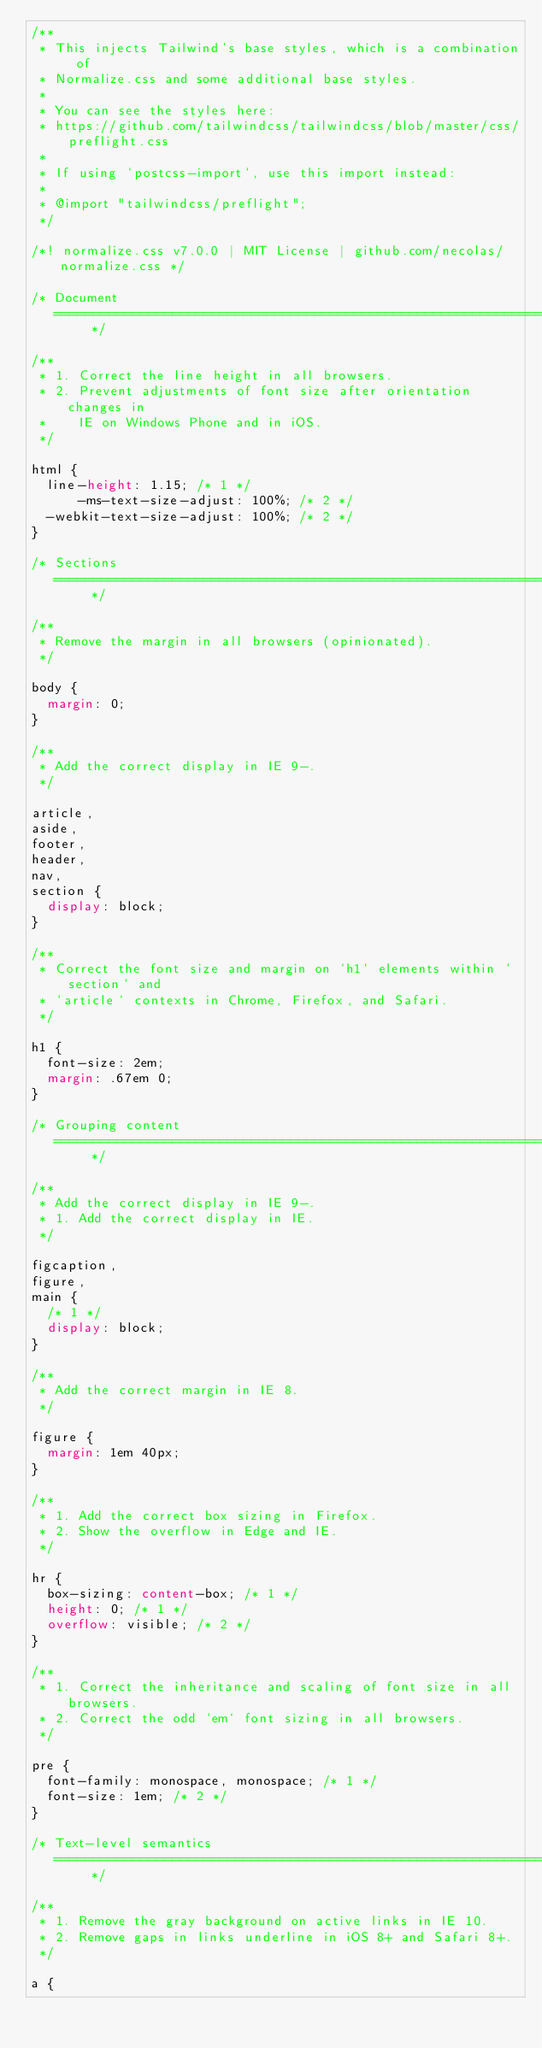<code> <loc_0><loc_0><loc_500><loc_500><_CSS_>/**
 * This injects Tailwind's base styles, which is a combination of
 * Normalize.css and some additional base styles.
 *
 * You can see the styles here:
 * https://github.com/tailwindcss/tailwindcss/blob/master/css/preflight.css
 *
 * If using `postcss-import`, use this import instead:
 *
 * @import "tailwindcss/preflight";
 */

/*! normalize.css v7.0.0 | MIT License | github.com/necolas/normalize.css */

/* Document
   ========================================================================== */

/**
 * 1. Correct the line height in all browsers.
 * 2. Prevent adjustments of font size after orientation changes in
 *    IE on Windows Phone and in iOS.
 */

html {
  line-height: 1.15; /* 1 */
      -ms-text-size-adjust: 100%; /* 2 */
  -webkit-text-size-adjust: 100%; /* 2 */
}

/* Sections
   ========================================================================== */

/**
 * Remove the margin in all browsers (opinionated).
 */

body {
  margin: 0;
}

/**
 * Add the correct display in IE 9-.
 */

article,
aside,
footer,
header,
nav,
section {
  display: block;
}

/**
 * Correct the font size and margin on `h1` elements within `section` and
 * `article` contexts in Chrome, Firefox, and Safari.
 */

h1 {
  font-size: 2em;
  margin: .67em 0;
}

/* Grouping content
   ========================================================================== */

/**
 * Add the correct display in IE 9-.
 * 1. Add the correct display in IE.
 */

figcaption,
figure,
main {
  /* 1 */
  display: block;
}

/**
 * Add the correct margin in IE 8.
 */

figure {
  margin: 1em 40px;
}

/**
 * 1. Add the correct box sizing in Firefox.
 * 2. Show the overflow in Edge and IE.
 */

hr {
  box-sizing: content-box; /* 1 */
  height: 0; /* 1 */
  overflow: visible; /* 2 */
}

/**
 * 1. Correct the inheritance and scaling of font size in all browsers.
 * 2. Correct the odd `em` font sizing in all browsers.
 */

pre {
  font-family: monospace, monospace; /* 1 */
  font-size: 1em; /* 2 */
}

/* Text-level semantics
   ========================================================================== */

/**
 * 1. Remove the gray background on active links in IE 10.
 * 2. Remove gaps in links underline in iOS 8+ and Safari 8+.
 */

a {</code> 